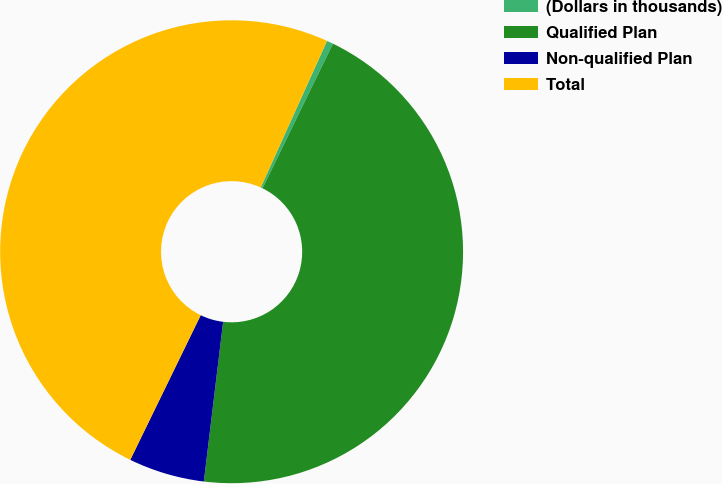Convert chart to OTSL. <chart><loc_0><loc_0><loc_500><loc_500><pie_chart><fcel>(Dollars in thousands)<fcel>Qualified Plan<fcel>Non-qualified Plan<fcel>Total<nl><fcel>0.45%<fcel>44.7%<fcel>5.3%<fcel>49.55%<nl></chart> 